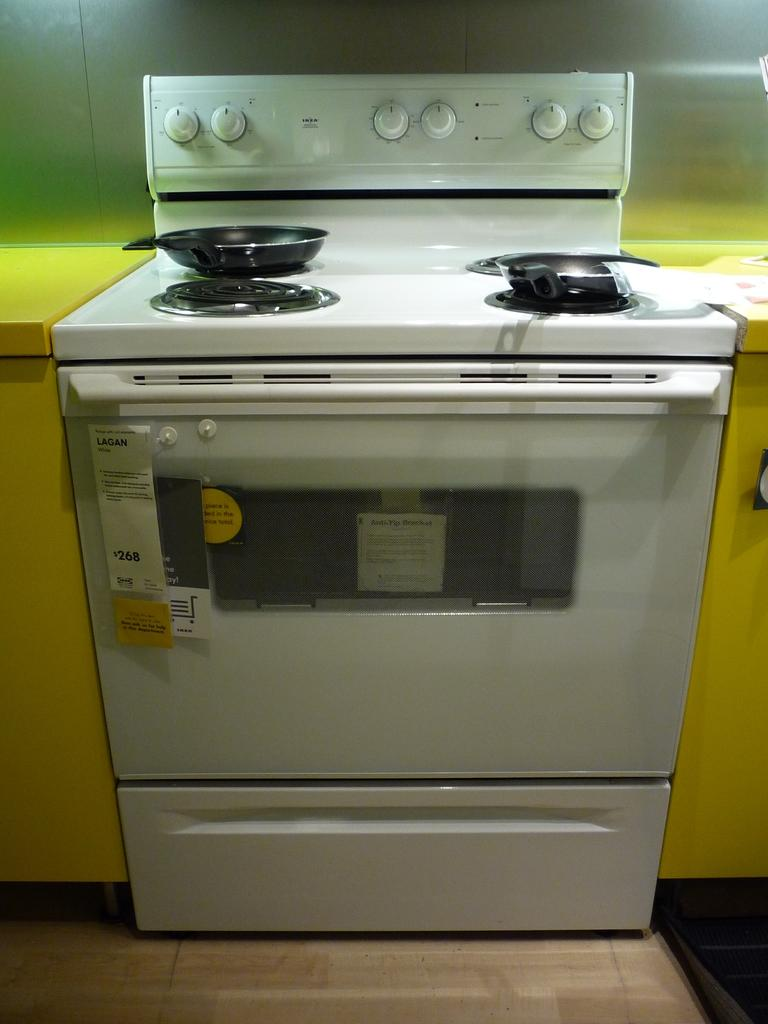What type of appliance is present in the image? There is a microwave oven in the image. What other cooking appliance can be seen in the image? There is a stove in the image. What are the pans used for in the image? The pans are used for cooking on the stove. What else can be seen in the image besides the appliances and pans? There are other objects in the image. What is visible in the background of the image? There is a wall visible in the background of the image. Can you see any clouds in the image? No, there are no clouds visible in the image. Is there a note attached to the wall in the image? There is no mention of a note in the provided facts, so we cannot determine if one is present. 